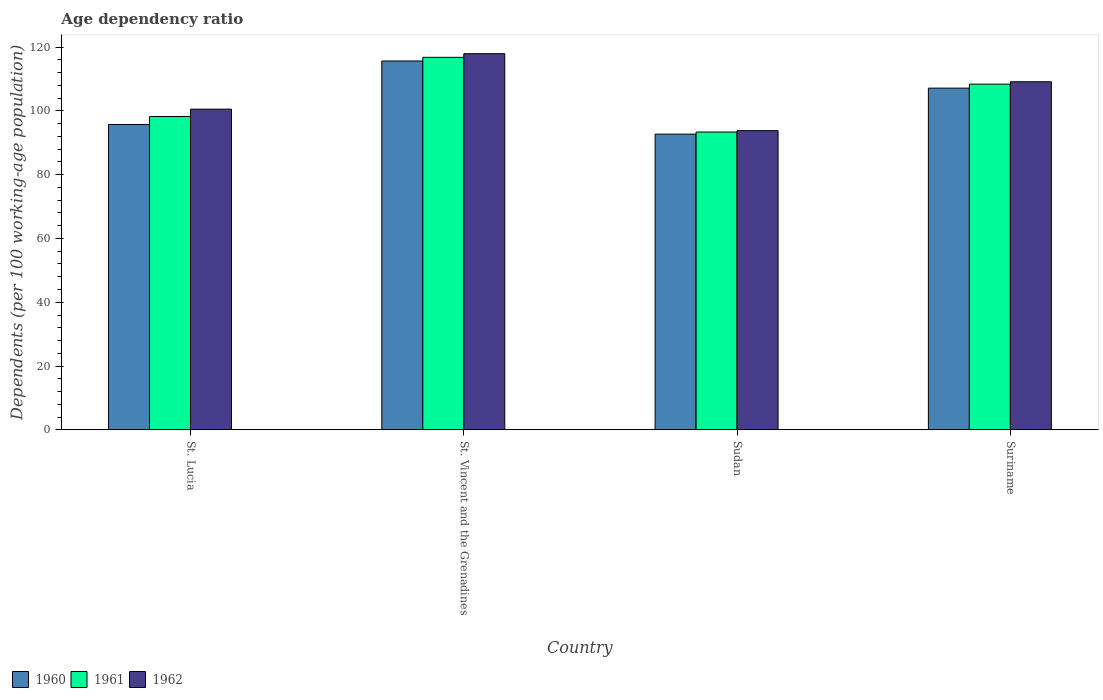Are the number of bars per tick equal to the number of legend labels?
Offer a very short reply. Yes. What is the label of the 1st group of bars from the left?
Your answer should be compact. St. Lucia. In how many cases, is the number of bars for a given country not equal to the number of legend labels?
Make the answer very short. 0. What is the age dependency ratio in in 1962 in Suriname?
Make the answer very short. 109.15. Across all countries, what is the maximum age dependency ratio in in 1960?
Provide a short and direct response. 115.67. Across all countries, what is the minimum age dependency ratio in in 1960?
Your response must be concise. 92.73. In which country was the age dependency ratio in in 1961 maximum?
Your response must be concise. St. Vincent and the Grenadines. In which country was the age dependency ratio in in 1960 minimum?
Provide a succinct answer. Sudan. What is the total age dependency ratio in in 1960 in the graph?
Give a very brief answer. 411.29. What is the difference between the age dependency ratio in in 1962 in St. Vincent and the Grenadines and that in Suriname?
Your answer should be compact. 8.81. What is the difference between the age dependency ratio in in 1961 in St. Vincent and the Grenadines and the age dependency ratio in in 1962 in St. Lucia?
Your answer should be compact. 16.25. What is the average age dependency ratio in in 1960 per country?
Your answer should be very brief. 102.82. What is the difference between the age dependency ratio in of/in 1962 and age dependency ratio in of/in 1961 in Sudan?
Provide a short and direct response. 0.44. In how many countries, is the age dependency ratio in in 1960 greater than 112 %?
Offer a terse response. 1. What is the ratio of the age dependency ratio in in 1961 in St. Vincent and the Grenadines to that in Sudan?
Keep it short and to the point. 1.25. Is the age dependency ratio in in 1961 in St. Lucia less than that in St. Vincent and the Grenadines?
Your answer should be very brief. Yes. What is the difference between the highest and the second highest age dependency ratio in in 1960?
Ensure brevity in your answer.  -8.51. What is the difference between the highest and the lowest age dependency ratio in in 1962?
Your response must be concise. 24.13. What does the 3rd bar from the left in Suriname represents?
Your answer should be compact. 1962. What is the difference between two consecutive major ticks on the Y-axis?
Provide a succinct answer. 20. Does the graph contain any zero values?
Offer a terse response. No. What is the title of the graph?
Provide a succinct answer. Age dependency ratio. Does "1966" appear as one of the legend labels in the graph?
Ensure brevity in your answer.  No. What is the label or title of the X-axis?
Provide a succinct answer. Country. What is the label or title of the Y-axis?
Provide a short and direct response. Dependents (per 100 working-age population). What is the Dependents (per 100 working-age population) of 1960 in St. Lucia?
Provide a short and direct response. 95.75. What is the Dependents (per 100 working-age population) in 1961 in St. Lucia?
Your response must be concise. 98.26. What is the Dependents (per 100 working-age population) of 1962 in St. Lucia?
Keep it short and to the point. 100.56. What is the Dependents (per 100 working-age population) of 1960 in St. Vincent and the Grenadines?
Provide a short and direct response. 115.67. What is the Dependents (per 100 working-age population) in 1961 in St. Vincent and the Grenadines?
Your response must be concise. 116.81. What is the Dependents (per 100 working-age population) of 1962 in St. Vincent and the Grenadines?
Give a very brief answer. 117.96. What is the Dependents (per 100 working-age population) of 1960 in Sudan?
Keep it short and to the point. 92.73. What is the Dependents (per 100 working-age population) in 1961 in Sudan?
Offer a very short reply. 93.39. What is the Dependents (per 100 working-age population) in 1962 in Sudan?
Make the answer very short. 93.83. What is the Dependents (per 100 working-age population) in 1960 in Suriname?
Provide a succinct answer. 107.16. What is the Dependents (per 100 working-age population) in 1961 in Suriname?
Offer a terse response. 108.4. What is the Dependents (per 100 working-age population) in 1962 in Suriname?
Keep it short and to the point. 109.15. Across all countries, what is the maximum Dependents (per 100 working-age population) in 1960?
Your response must be concise. 115.67. Across all countries, what is the maximum Dependents (per 100 working-age population) of 1961?
Ensure brevity in your answer.  116.81. Across all countries, what is the maximum Dependents (per 100 working-age population) of 1962?
Your answer should be very brief. 117.96. Across all countries, what is the minimum Dependents (per 100 working-age population) of 1960?
Offer a terse response. 92.73. Across all countries, what is the minimum Dependents (per 100 working-age population) in 1961?
Offer a terse response. 93.39. Across all countries, what is the minimum Dependents (per 100 working-age population) in 1962?
Give a very brief answer. 93.83. What is the total Dependents (per 100 working-age population) in 1960 in the graph?
Provide a succinct answer. 411.29. What is the total Dependents (per 100 working-age population) of 1961 in the graph?
Make the answer very short. 416.86. What is the total Dependents (per 100 working-age population) of 1962 in the graph?
Make the answer very short. 421.5. What is the difference between the Dependents (per 100 working-age population) of 1960 in St. Lucia and that in St. Vincent and the Grenadines?
Your answer should be very brief. -19.92. What is the difference between the Dependents (per 100 working-age population) of 1961 in St. Lucia and that in St. Vincent and the Grenadines?
Offer a terse response. -18.56. What is the difference between the Dependents (per 100 working-age population) of 1962 in St. Lucia and that in St. Vincent and the Grenadines?
Your answer should be compact. -17.4. What is the difference between the Dependents (per 100 working-age population) in 1960 in St. Lucia and that in Sudan?
Your response must be concise. 3.02. What is the difference between the Dependents (per 100 working-age population) of 1961 in St. Lucia and that in Sudan?
Your answer should be very brief. 4.87. What is the difference between the Dependents (per 100 working-age population) in 1962 in St. Lucia and that in Sudan?
Offer a terse response. 6.73. What is the difference between the Dependents (per 100 working-age population) in 1960 in St. Lucia and that in Suriname?
Keep it short and to the point. -11.41. What is the difference between the Dependents (per 100 working-age population) of 1961 in St. Lucia and that in Suriname?
Provide a succinct answer. -10.15. What is the difference between the Dependents (per 100 working-age population) of 1962 in St. Lucia and that in Suriname?
Give a very brief answer. -8.59. What is the difference between the Dependents (per 100 working-age population) of 1960 in St. Vincent and the Grenadines and that in Sudan?
Your response must be concise. 22.94. What is the difference between the Dependents (per 100 working-age population) in 1961 in St. Vincent and the Grenadines and that in Sudan?
Make the answer very short. 23.42. What is the difference between the Dependents (per 100 working-age population) of 1962 in St. Vincent and the Grenadines and that in Sudan?
Offer a very short reply. 24.13. What is the difference between the Dependents (per 100 working-age population) in 1960 in St. Vincent and the Grenadines and that in Suriname?
Your response must be concise. 8.51. What is the difference between the Dependents (per 100 working-age population) of 1961 in St. Vincent and the Grenadines and that in Suriname?
Your answer should be compact. 8.41. What is the difference between the Dependents (per 100 working-age population) of 1962 in St. Vincent and the Grenadines and that in Suriname?
Your response must be concise. 8.81. What is the difference between the Dependents (per 100 working-age population) in 1960 in Sudan and that in Suriname?
Your response must be concise. -14.43. What is the difference between the Dependents (per 100 working-age population) of 1961 in Sudan and that in Suriname?
Offer a terse response. -15.02. What is the difference between the Dependents (per 100 working-age population) in 1962 in Sudan and that in Suriname?
Provide a short and direct response. -15.32. What is the difference between the Dependents (per 100 working-age population) of 1960 in St. Lucia and the Dependents (per 100 working-age population) of 1961 in St. Vincent and the Grenadines?
Your answer should be compact. -21.07. What is the difference between the Dependents (per 100 working-age population) in 1960 in St. Lucia and the Dependents (per 100 working-age population) in 1962 in St. Vincent and the Grenadines?
Keep it short and to the point. -22.21. What is the difference between the Dependents (per 100 working-age population) of 1961 in St. Lucia and the Dependents (per 100 working-age population) of 1962 in St. Vincent and the Grenadines?
Provide a succinct answer. -19.7. What is the difference between the Dependents (per 100 working-age population) in 1960 in St. Lucia and the Dependents (per 100 working-age population) in 1961 in Sudan?
Provide a succinct answer. 2.36. What is the difference between the Dependents (per 100 working-age population) in 1960 in St. Lucia and the Dependents (per 100 working-age population) in 1962 in Sudan?
Offer a terse response. 1.92. What is the difference between the Dependents (per 100 working-age population) in 1961 in St. Lucia and the Dependents (per 100 working-age population) in 1962 in Sudan?
Offer a terse response. 4.43. What is the difference between the Dependents (per 100 working-age population) in 1960 in St. Lucia and the Dependents (per 100 working-age population) in 1961 in Suriname?
Make the answer very short. -12.66. What is the difference between the Dependents (per 100 working-age population) of 1960 in St. Lucia and the Dependents (per 100 working-age population) of 1962 in Suriname?
Give a very brief answer. -13.4. What is the difference between the Dependents (per 100 working-age population) of 1961 in St. Lucia and the Dependents (per 100 working-age population) of 1962 in Suriname?
Provide a short and direct response. -10.89. What is the difference between the Dependents (per 100 working-age population) of 1960 in St. Vincent and the Grenadines and the Dependents (per 100 working-age population) of 1961 in Sudan?
Ensure brevity in your answer.  22.28. What is the difference between the Dependents (per 100 working-age population) of 1960 in St. Vincent and the Grenadines and the Dependents (per 100 working-age population) of 1962 in Sudan?
Provide a succinct answer. 21.84. What is the difference between the Dependents (per 100 working-age population) in 1961 in St. Vincent and the Grenadines and the Dependents (per 100 working-age population) in 1962 in Sudan?
Your answer should be very brief. 22.98. What is the difference between the Dependents (per 100 working-age population) of 1960 in St. Vincent and the Grenadines and the Dependents (per 100 working-age population) of 1961 in Suriname?
Keep it short and to the point. 7.26. What is the difference between the Dependents (per 100 working-age population) in 1960 in St. Vincent and the Grenadines and the Dependents (per 100 working-age population) in 1962 in Suriname?
Your answer should be very brief. 6.52. What is the difference between the Dependents (per 100 working-age population) in 1961 in St. Vincent and the Grenadines and the Dependents (per 100 working-age population) in 1962 in Suriname?
Your response must be concise. 7.66. What is the difference between the Dependents (per 100 working-age population) of 1960 in Sudan and the Dependents (per 100 working-age population) of 1961 in Suriname?
Your answer should be compact. -15.68. What is the difference between the Dependents (per 100 working-age population) of 1960 in Sudan and the Dependents (per 100 working-age population) of 1962 in Suriname?
Your response must be concise. -16.42. What is the difference between the Dependents (per 100 working-age population) in 1961 in Sudan and the Dependents (per 100 working-age population) in 1962 in Suriname?
Offer a very short reply. -15.76. What is the average Dependents (per 100 working-age population) of 1960 per country?
Provide a short and direct response. 102.82. What is the average Dependents (per 100 working-age population) in 1961 per country?
Keep it short and to the point. 104.22. What is the average Dependents (per 100 working-age population) of 1962 per country?
Make the answer very short. 105.37. What is the difference between the Dependents (per 100 working-age population) of 1960 and Dependents (per 100 working-age population) of 1961 in St. Lucia?
Offer a very short reply. -2.51. What is the difference between the Dependents (per 100 working-age population) in 1960 and Dependents (per 100 working-age population) in 1962 in St. Lucia?
Keep it short and to the point. -4.81. What is the difference between the Dependents (per 100 working-age population) in 1961 and Dependents (per 100 working-age population) in 1962 in St. Lucia?
Your answer should be very brief. -2.3. What is the difference between the Dependents (per 100 working-age population) of 1960 and Dependents (per 100 working-age population) of 1961 in St. Vincent and the Grenadines?
Make the answer very short. -1.15. What is the difference between the Dependents (per 100 working-age population) of 1960 and Dependents (per 100 working-age population) of 1962 in St. Vincent and the Grenadines?
Keep it short and to the point. -2.29. What is the difference between the Dependents (per 100 working-age population) of 1961 and Dependents (per 100 working-age population) of 1962 in St. Vincent and the Grenadines?
Your response must be concise. -1.15. What is the difference between the Dependents (per 100 working-age population) in 1960 and Dependents (per 100 working-age population) in 1961 in Sudan?
Your response must be concise. -0.66. What is the difference between the Dependents (per 100 working-age population) of 1960 and Dependents (per 100 working-age population) of 1962 in Sudan?
Your response must be concise. -1.1. What is the difference between the Dependents (per 100 working-age population) in 1961 and Dependents (per 100 working-age population) in 1962 in Sudan?
Provide a succinct answer. -0.44. What is the difference between the Dependents (per 100 working-age population) of 1960 and Dependents (per 100 working-age population) of 1961 in Suriname?
Make the answer very short. -1.25. What is the difference between the Dependents (per 100 working-age population) in 1960 and Dependents (per 100 working-age population) in 1962 in Suriname?
Make the answer very short. -1.99. What is the difference between the Dependents (per 100 working-age population) of 1961 and Dependents (per 100 working-age population) of 1962 in Suriname?
Your answer should be compact. -0.74. What is the ratio of the Dependents (per 100 working-age population) of 1960 in St. Lucia to that in St. Vincent and the Grenadines?
Your answer should be compact. 0.83. What is the ratio of the Dependents (per 100 working-age population) in 1961 in St. Lucia to that in St. Vincent and the Grenadines?
Make the answer very short. 0.84. What is the ratio of the Dependents (per 100 working-age population) in 1962 in St. Lucia to that in St. Vincent and the Grenadines?
Provide a short and direct response. 0.85. What is the ratio of the Dependents (per 100 working-age population) of 1960 in St. Lucia to that in Sudan?
Provide a succinct answer. 1.03. What is the ratio of the Dependents (per 100 working-age population) of 1961 in St. Lucia to that in Sudan?
Your response must be concise. 1.05. What is the ratio of the Dependents (per 100 working-age population) in 1962 in St. Lucia to that in Sudan?
Ensure brevity in your answer.  1.07. What is the ratio of the Dependents (per 100 working-age population) of 1960 in St. Lucia to that in Suriname?
Ensure brevity in your answer.  0.89. What is the ratio of the Dependents (per 100 working-age population) of 1961 in St. Lucia to that in Suriname?
Give a very brief answer. 0.91. What is the ratio of the Dependents (per 100 working-age population) in 1962 in St. Lucia to that in Suriname?
Make the answer very short. 0.92. What is the ratio of the Dependents (per 100 working-age population) in 1960 in St. Vincent and the Grenadines to that in Sudan?
Offer a very short reply. 1.25. What is the ratio of the Dependents (per 100 working-age population) of 1961 in St. Vincent and the Grenadines to that in Sudan?
Offer a terse response. 1.25. What is the ratio of the Dependents (per 100 working-age population) of 1962 in St. Vincent and the Grenadines to that in Sudan?
Offer a terse response. 1.26. What is the ratio of the Dependents (per 100 working-age population) in 1960 in St. Vincent and the Grenadines to that in Suriname?
Your response must be concise. 1.08. What is the ratio of the Dependents (per 100 working-age population) in 1961 in St. Vincent and the Grenadines to that in Suriname?
Your answer should be very brief. 1.08. What is the ratio of the Dependents (per 100 working-age population) of 1962 in St. Vincent and the Grenadines to that in Suriname?
Provide a succinct answer. 1.08. What is the ratio of the Dependents (per 100 working-age population) of 1960 in Sudan to that in Suriname?
Give a very brief answer. 0.87. What is the ratio of the Dependents (per 100 working-age population) in 1961 in Sudan to that in Suriname?
Keep it short and to the point. 0.86. What is the ratio of the Dependents (per 100 working-age population) of 1962 in Sudan to that in Suriname?
Give a very brief answer. 0.86. What is the difference between the highest and the second highest Dependents (per 100 working-age population) in 1960?
Provide a short and direct response. 8.51. What is the difference between the highest and the second highest Dependents (per 100 working-age population) in 1961?
Offer a very short reply. 8.41. What is the difference between the highest and the second highest Dependents (per 100 working-age population) of 1962?
Your response must be concise. 8.81. What is the difference between the highest and the lowest Dependents (per 100 working-age population) in 1960?
Give a very brief answer. 22.94. What is the difference between the highest and the lowest Dependents (per 100 working-age population) in 1961?
Provide a short and direct response. 23.42. What is the difference between the highest and the lowest Dependents (per 100 working-age population) of 1962?
Your answer should be very brief. 24.13. 